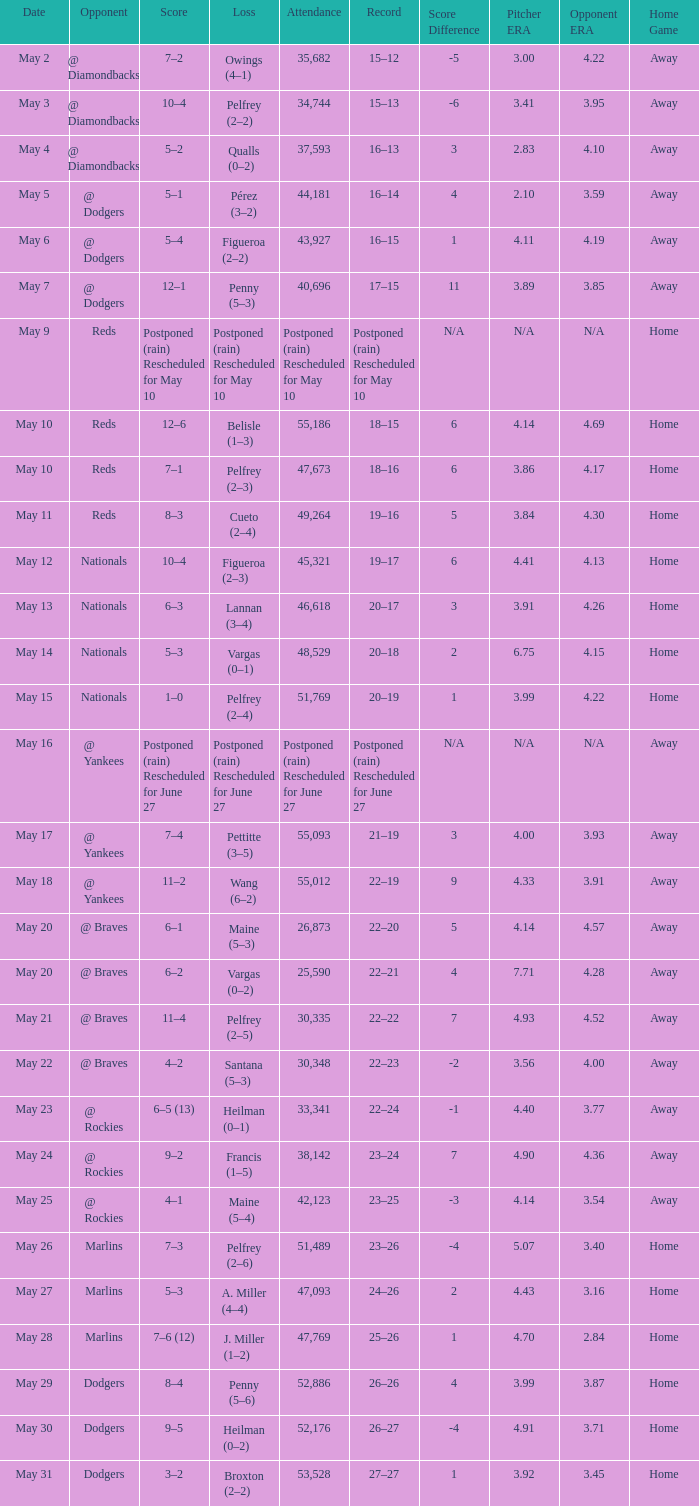Record of 19–16 occurred on what date? May 11. Give me the full table as a dictionary. {'header': ['Date', 'Opponent', 'Score', 'Loss', 'Attendance', 'Record', 'Score Difference', 'Pitcher ERA', 'Opponent ERA', 'Home Game'], 'rows': [['May 2', '@ Diamondbacks', '7–2', 'Owings (4–1)', '35,682', '15–12', '-5', '3.00', '4.22', 'Away'], ['May 3', '@ Diamondbacks', '10–4', 'Pelfrey (2–2)', '34,744', '15–13', '-6', '3.41', '3.95', 'Away'], ['May 4', '@ Diamondbacks', '5–2', 'Qualls (0–2)', '37,593', '16–13', '3', '2.83', '4.10', 'Away'], ['May 5', '@ Dodgers', '5–1', 'Pérez (3–2)', '44,181', '16–14', '4', '2.10', '3.59', 'Away'], ['May 6', '@ Dodgers', '5–4', 'Figueroa (2–2)', '43,927', '16–15', '1', '4.11', '4.19', 'Away'], ['May 7', '@ Dodgers', '12–1', 'Penny (5–3)', '40,696', '17–15', '11', '3.89', '3.85', 'Away'], ['May 9', 'Reds', 'Postponed (rain) Rescheduled for May 10', 'Postponed (rain) Rescheduled for May 10', 'Postponed (rain) Rescheduled for May 10', 'Postponed (rain) Rescheduled for May 10', 'N/A', 'N/A', 'N/A', 'Home'], ['May 10', 'Reds', '12–6', 'Belisle (1–3)', '55,186', '18–15', '6', '4.14', '4.69', 'Home'], ['May 10', 'Reds', '7–1', 'Pelfrey (2–3)', '47,673', '18–16', '6', '3.86', '4.17', 'Home'], ['May 11', 'Reds', '8–3', 'Cueto (2–4)', '49,264', '19–16', '5', '3.84', '4.30', 'Home'], ['May 12', 'Nationals', '10–4', 'Figueroa (2–3)', '45,321', '19–17', '6', '4.41', '4.13', 'Home'], ['May 13', 'Nationals', '6–3', 'Lannan (3–4)', '46,618', '20–17', '3', '3.91', '4.26', 'Home'], ['May 14', 'Nationals', '5–3', 'Vargas (0–1)', '48,529', '20–18', '2', '6.75', '4.15', 'Home'], ['May 15', 'Nationals', '1–0', 'Pelfrey (2–4)', '51,769', '20–19', '1', '3.99', '4.22', 'Home'], ['May 16', '@ Yankees', 'Postponed (rain) Rescheduled for June 27', 'Postponed (rain) Rescheduled for June 27', 'Postponed (rain) Rescheduled for June 27', 'Postponed (rain) Rescheduled for June 27', 'N/A', 'N/A', 'N/A', 'Away'], ['May 17', '@ Yankees', '7–4', 'Pettitte (3–5)', '55,093', '21–19', '3', '4.00', '3.93', 'Away'], ['May 18', '@ Yankees', '11–2', 'Wang (6–2)', '55,012', '22–19', '9', '4.33', '3.91', 'Away'], ['May 20', '@ Braves', '6–1', 'Maine (5–3)', '26,873', '22–20', '5', '4.14', '4.57', 'Away'], ['May 20', '@ Braves', '6–2', 'Vargas (0–2)', '25,590', '22–21', '4', '7.71', '4.28', 'Away'], ['May 21', '@ Braves', '11–4', 'Pelfrey (2–5)', '30,335', '22–22', '7', '4.93', '4.52', 'Away'], ['May 22', '@ Braves', '4–2', 'Santana (5–3)', '30,348', '22–23', '-2', '3.56', '4.00', 'Away'], ['May 23', '@ Rockies', '6–5 (13)', 'Heilman (0–1)', '33,341', '22–24', '-1', '4.40', '3.77', 'Away'], ['May 24', '@ Rockies', '9–2', 'Francis (1–5)', '38,142', '23–24', '7', '4.90', '4.36', 'Away'], ['May 25', '@ Rockies', '4–1', 'Maine (5–4)', '42,123', '23–25', '-3', '4.14', '3.54', 'Away'], ['May 26', 'Marlins', '7–3', 'Pelfrey (2–6)', '51,489', '23–26', '-4', '5.07', '3.40', 'Home'], ['May 27', 'Marlins', '5–3', 'A. Miller (4–4)', '47,093', '24–26', '2', '4.43', '3.16', 'Home'], ['May 28', 'Marlins', '7–6 (12)', 'J. Miller (1–2)', '47,769', '25–26', '1', '4.70', '2.84', 'Home'], ['May 29', 'Dodgers', '8–4', 'Penny (5–6)', '52,886', '26–26', '4', '3.99', '3.87', 'Home'], ['May 30', 'Dodgers', '9–5', 'Heilman (0–2)', '52,176', '26–27', '-4', '4.91', '3.71', 'Home'], ['May 31', 'Dodgers', '3–2', 'Broxton (2–2)', '53,528', '27–27', '1', '3.92', '3.45', 'Home']]} 